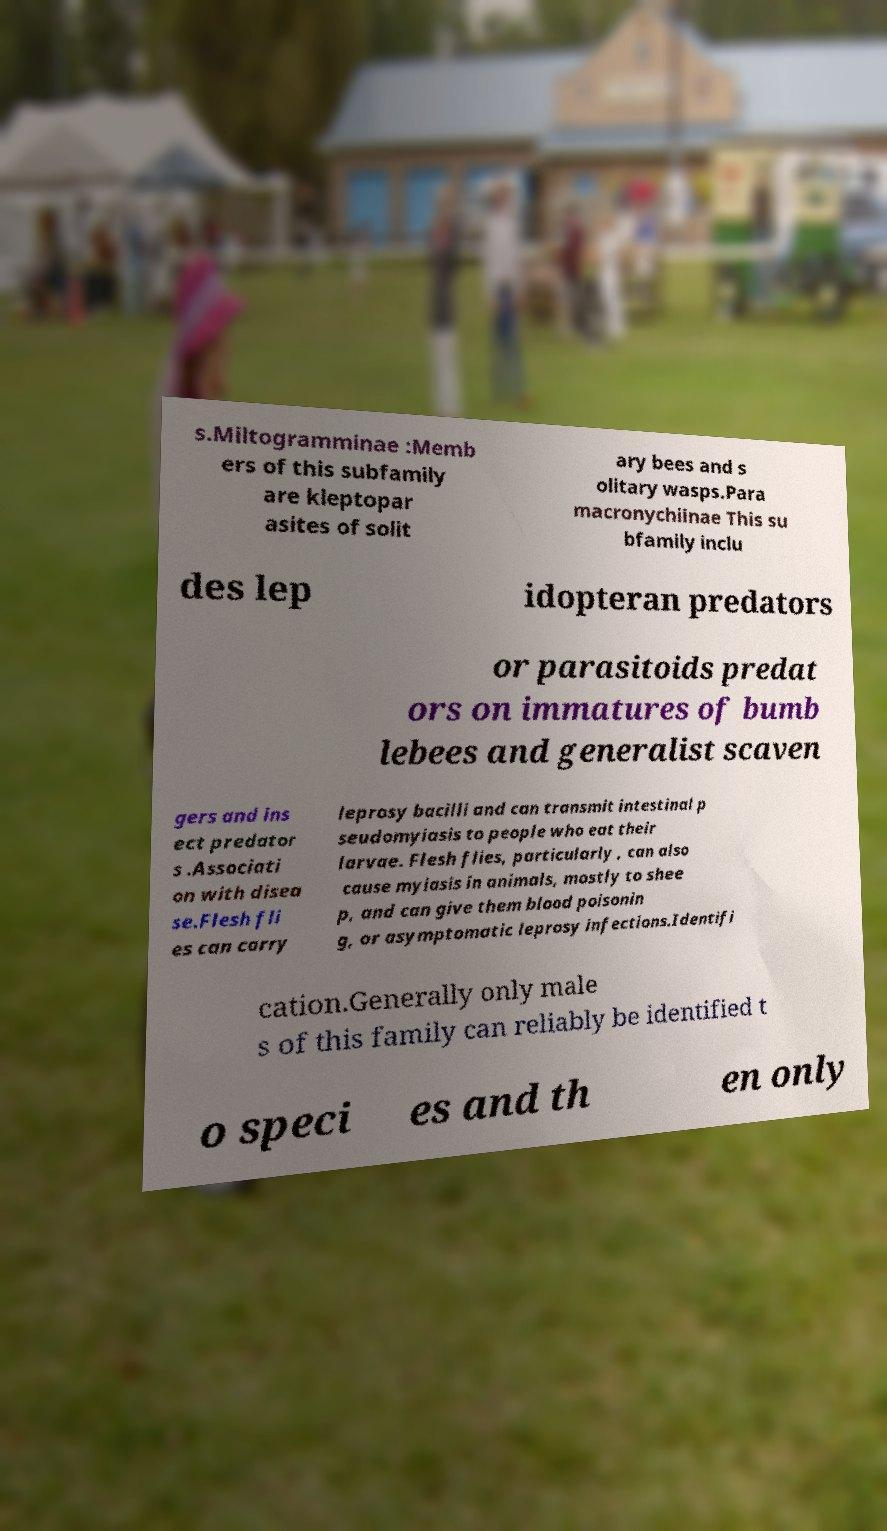Could you extract and type out the text from this image? s.Miltogramminae :Memb ers of this subfamily are kleptopar asites of solit ary bees and s olitary wasps.Para macronychiinae This su bfamily inclu des lep idopteran predators or parasitoids predat ors on immatures of bumb lebees and generalist scaven gers and ins ect predator s .Associati on with disea se.Flesh fli es can carry leprosy bacilli and can transmit intestinal p seudomyiasis to people who eat their larvae. Flesh flies, particularly , can also cause myiasis in animals, mostly to shee p, and can give them blood poisonin g, or asymptomatic leprosy infections.Identifi cation.Generally only male s of this family can reliably be identified t o speci es and th en only 